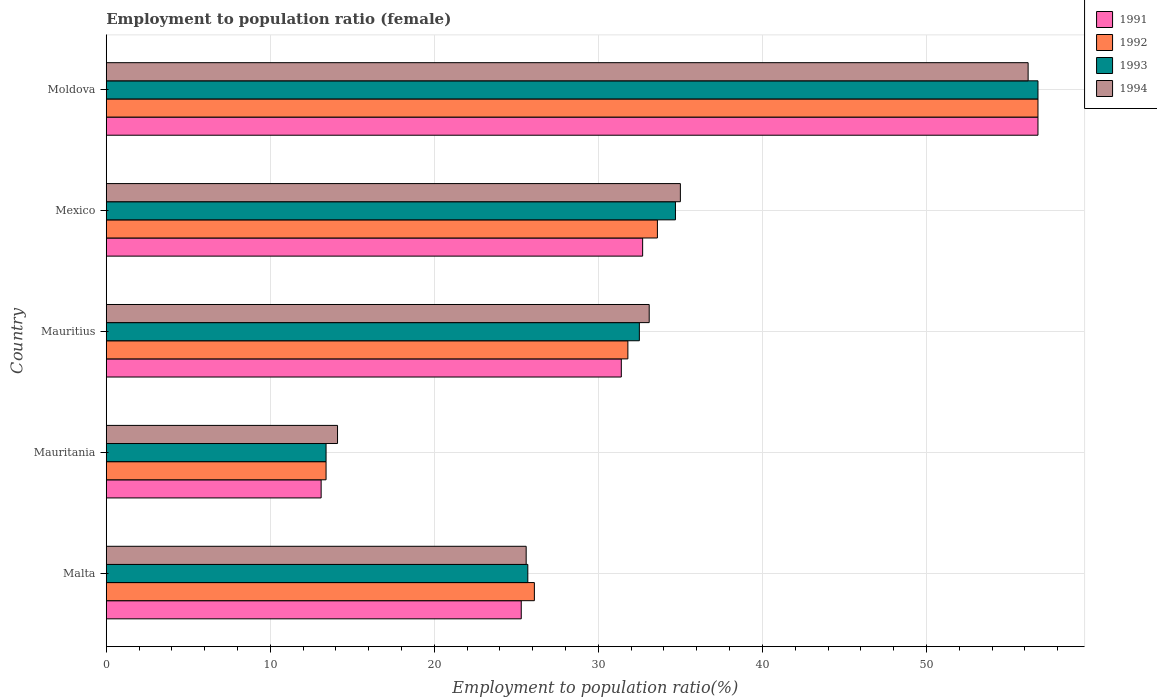How many groups of bars are there?
Provide a succinct answer. 5. Are the number of bars per tick equal to the number of legend labels?
Keep it short and to the point. Yes. How many bars are there on the 4th tick from the bottom?
Your answer should be very brief. 4. What is the label of the 5th group of bars from the top?
Give a very brief answer. Malta. What is the employment to population ratio in 1991 in Moldova?
Keep it short and to the point. 56.8. Across all countries, what is the maximum employment to population ratio in 1991?
Provide a succinct answer. 56.8. Across all countries, what is the minimum employment to population ratio in 1992?
Ensure brevity in your answer.  13.4. In which country was the employment to population ratio in 1994 maximum?
Offer a terse response. Moldova. In which country was the employment to population ratio in 1994 minimum?
Ensure brevity in your answer.  Mauritania. What is the total employment to population ratio in 1992 in the graph?
Keep it short and to the point. 161.7. What is the difference between the employment to population ratio in 1993 in Malta and that in Moldova?
Make the answer very short. -31.1. What is the difference between the employment to population ratio in 1994 in Mauritania and the employment to population ratio in 1992 in Mexico?
Provide a short and direct response. -19.5. What is the average employment to population ratio in 1992 per country?
Provide a succinct answer. 32.34. What is the difference between the employment to population ratio in 1993 and employment to population ratio in 1994 in Mauritius?
Your answer should be very brief. -0.6. In how many countries, is the employment to population ratio in 1992 greater than 4 %?
Your answer should be very brief. 5. What is the ratio of the employment to population ratio in 1993 in Mauritania to that in Mexico?
Keep it short and to the point. 0.39. Is the employment to population ratio in 1994 in Mauritius less than that in Mexico?
Your answer should be very brief. Yes. Is the difference between the employment to population ratio in 1993 in Malta and Mexico greater than the difference between the employment to population ratio in 1994 in Malta and Mexico?
Your answer should be compact. Yes. What is the difference between the highest and the second highest employment to population ratio in 1993?
Offer a terse response. 22.1. What is the difference between the highest and the lowest employment to population ratio in 1994?
Your answer should be compact. 42.1. In how many countries, is the employment to population ratio in 1992 greater than the average employment to population ratio in 1992 taken over all countries?
Make the answer very short. 2. What does the 1st bar from the bottom in Mexico represents?
Keep it short and to the point. 1991. Is it the case that in every country, the sum of the employment to population ratio in 1993 and employment to population ratio in 1992 is greater than the employment to population ratio in 1991?
Ensure brevity in your answer.  Yes. How many bars are there?
Give a very brief answer. 20. How many countries are there in the graph?
Your response must be concise. 5. Are the values on the major ticks of X-axis written in scientific E-notation?
Your response must be concise. No. How many legend labels are there?
Give a very brief answer. 4. How are the legend labels stacked?
Offer a very short reply. Vertical. What is the title of the graph?
Ensure brevity in your answer.  Employment to population ratio (female). What is the Employment to population ratio(%) in 1991 in Malta?
Keep it short and to the point. 25.3. What is the Employment to population ratio(%) of 1992 in Malta?
Offer a terse response. 26.1. What is the Employment to population ratio(%) in 1993 in Malta?
Give a very brief answer. 25.7. What is the Employment to population ratio(%) of 1994 in Malta?
Your response must be concise. 25.6. What is the Employment to population ratio(%) of 1991 in Mauritania?
Provide a succinct answer. 13.1. What is the Employment to population ratio(%) of 1992 in Mauritania?
Your answer should be compact. 13.4. What is the Employment to population ratio(%) in 1993 in Mauritania?
Offer a very short reply. 13.4. What is the Employment to population ratio(%) of 1994 in Mauritania?
Offer a very short reply. 14.1. What is the Employment to population ratio(%) of 1991 in Mauritius?
Provide a succinct answer. 31.4. What is the Employment to population ratio(%) of 1992 in Mauritius?
Ensure brevity in your answer.  31.8. What is the Employment to population ratio(%) in 1993 in Mauritius?
Keep it short and to the point. 32.5. What is the Employment to population ratio(%) in 1994 in Mauritius?
Make the answer very short. 33.1. What is the Employment to population ratio(%) of 1991 in Mexico?
Offer a terse response. 32.7. What is the Employment to population ratio(%) of 1992 in Mexico?
Offer a very short reply. 33.6. What is the Employment to population ratio(%) of 1993 in Mexico?
Offer a very short reply. 34.7. What is the Employment to population ratio(%) of 1991 in Moldova?
Provide a short and direct response. 56.8. What is the Employment to population ratio(%) of 1992 in Moldova?
Provide a short and direct response. 56.8. What is the Employment to population ratio(%) of 1993 in Moldova?
Provide a succinct answer. 56.8. What is the Employment to population ratio(%) in 1994 in Moldova?
Provide a short and direct response. 56.2. Across all countries, what is the maximum Employment to population ratio(%) in 1991?
Give a very brief answer. 56.8. Across all countries, what is the maximum Employment to population ratio(%) of 1992?
Give a very brief answer. 56.8. Across all countries, what is the maximum Employment to population ratio(%) of 1993?
Provide a succinct answer. 56.8. Across all countries, what is the maximum Employment to population ratio(%) of 1994?
Ensure brevity in your answer.  56.2. Across all countries, what is the minimum Employment to population ratio(%) in 1991?
Provide a short and direct response. 13.1. Across all countries, what is the minimum Employment to population ratio(%) in 1992?
Give a very brief answer. 13.4. Across all countries, what is the minimum Employment to population ratio(%) of 1993?
Make the answer very short. 13.4. Across all countries, what is the minimum Employment to population ratio(%) in 1994?
Your response must be concise. 14.1. What is the total Employment to population ratio(%) of 1991 in the graph?
Your answer should be very brief. 159.3. What is the total Employment to population ratio(%) in 1992 in the graph?
Provide a short and direct response. 161.7. What is the total Employment to population ratio(%) of 1993 in the graph?
Provide a short and direct response. 163.1. What is the total Employment to population ratio(%) in 1994 in the graph?
Provide a short and direct response. 164. What is the difference between the Employment to population ratio(%) in 1992 in Malta and that in Mauritania?
Give a very brief answer. 12.7. What is the difference between the Employment to population ratio(%) in 1994 in Malta and that in Mauritania?
Your response must be concise. 11.5. What is the difference between the Employment to population ratio(%) in 1993 in Malta and that in Mauritius?
Give a very brief answer. -6.8. What is the difference between the Employment to population ratio(%) in 1994 in Malta and that in Mauritius?
Provide a succinct answer. -7.5. What is the difference between the Employment to population ratio(%) in 1992 in Malta and that in Mexico?
Your answer should be compact. -7.5. What is the difference between the Employment to population ratio(%) of 1991 in Malta and that in Moldova?
Your answer should be compact. -31.5. What is the difference between the Employment to population ratio(%) in 1992 in Malta and that in Moldova?
Make the answer very short. -30.7. What is the difference between the Employment to population ratio(%) in 1993 in Malta and that in Moldova?
Your response must be concise. -31.1. What is the difference between the Employment to population ratio(%) of 1994 in Malta and that in Moldova?
Provide a short and direct response. -30.6. What is the difference between the Employment to population ratio(%) in 1991 in Mauritania and that in Mauritius?
Make the answer very short. -18.3. What is the difference between the Employment to population ratio(%) in 1992 in Mauritania and that in Mauritius?
Your answer should be very brief. -18.4. What is the difference between the Employment to population ratio(%) of 1993 in Mauritania and that in Mauritius?
Your response must be concise. -19.1. What is the difference between the Employment to population ratio(%) in 1994 in Mauritania and that in Mauritius?
Your answer should be compact. -19. What is the difference between the Employment to population ratio(%) in 1991 in Mauritania and that in Mexico?
Keep it short and to the point. -19.6. What is the difference between the Employment to population ratio(%) of 1992 in Mauritania and that in Mexico?
Your response must be concise. -20.2. What is the difference between the Employment to population ratio(%) of 1993 in Mauritania and that in Mexico?
Provide a succinct answer. -21.3. What is the difference between the Employment to population ratio(%) of 1994 in Mauritania and that in Mexico?
Provide a short and direct response. -20.9. What is the difference between the Employment to population ratio(%) of 1991 in Mauritania and that in Moldova?
Ensure brevity in your answer.  -43.7. What is the difference between the Employment to population ratio(%) in 1992 in Mauritania and that in Moldova?
Offer a terse response. -43.4. What is the difference between the Employment to population ratio(%) in 1993 in Mauritania and that in Moldova?
Ensure brevity in your answer.  -43.4. What is the difference between the Employment to population ratio(%) in 1994 in Mauritania and that in Moldova?
Ensure brevity in your answer.  -42.1. What is the difference between the Employment to population ratio(%) in 1991 in Mauritius and that in Mexico?
Ensure brevity in your answer.  -1.3. What is the difference between the Employment to population ratio(%) of 1994 in Mauritius and that in Mexico?
Keep it short and to the point. -1.9. What is the difference between the Employment to population ratio(%) in 1991 in Mauritius and that in Moldova?
Give a very brief answer. -25.4. What is the difference between the Employment to population ratio(%) of 1993 in Mauritius and that in Moldova?
Ensure brevity in your answer.  -24.3. What is the difference between the Employment to population ratio(%) in 1994 in Mauritius and that in Moldova?
Ensure brevity in your answer.  -23.1. What is the difference between the Employment to population ratio(%) of 1991 in Mexico and that in Moldova?
Give a very brief answer. -24.1. What is the difference between the Employment to population ratio(%) of 1992 in Mexico and that in Moldova?
Make the answer very short. -23.2. What is the difference between the Employment to population ratio(%) of 1993 in Mexico and that in Moldova?
Ensure brevity in your answer.  -22.1. What is the difference between the Employment to population ratio(%) of 1994 in Mexico and that in Moldova?
Your answer should be compact. -21.2. What is the difference between the Employment to population ratio(%) of 1991 in Malta and the Employment to population ratio(%) of 1994 in Mauritania?
Offer a terse response. 11.2. What is the difference between the Employment to population ratio(%) in 1992 in Malta and the Employment to population ratio(%) in 1994 in Mauritania?
Give a very brief answer. 12. What is the difference between the Employment to population ratio(%) in 1991 in Malta and the Employment to population ratio(%) in 1992 in Mauritius?
Your answer should be compact. -6.5. What is the difference between the Employment to population ratio(%) of 1991 in Malta and the Employment to population ratio(%) of 1993 in Mauritius?
Ensure brevity in your answer.  -7.2. What is the difference between the Employment to population ratio(%) in 1993 in Malta and the Employment to population ratio(%) in 1994 in Mauritius?
Your answer should be very brief. -7.4. What is the difference between the Employment to population ratio(%) in 1991 in Malta and the Employment to population ratio(%) in 1992 in Mexico?
Provide a short and direct response. -8.3. What is the difference between the Employment to population ratio(%) in 1991 in Malta and the Employment to population ratio(%) in 1993 in Mexico?
Ensure brevity in your answer.  -9.4. What is the difference between the Employment to population ratio(%) in 1991 in Malta and the Employment to population ratio(%) in 1994 in Mexico?
Offer a terse response. -9.7. What is the difference between the Employment to population ratio(%) of 1993 in Malta and the Employment to population ratio(%) of 1994 in Mexico?
Ensure brevity in your answer.  -9.3. What is the difference between the Employment to population ratio(%) of 1991 in Malta and the Employment to population ratio(%) of 1992 in Moldova?
Make the answer very short. -31.5. What is the difference between the Employment to population ratio(%) in 1991 in Malta and the Employment to population ratio(%) in 1993 in Moldova?
Your answer should be very brief. -31.5. What is the difference between the Employment to population ratio(%) in 1991 in Malta and the Employment to population ratio(%) in 1994 in Moldova?
Provide a short and direct response. -30.9. What is the difference between the Employment to population ratio(%) of 1992 in Malta and the Employment to population ratio(%) of 1993 in Moldova?
Provide a succinct answer. -30.7. What is the difference between the Employment to population ratio(%) in 1992 in Malta and the Employment to population ratio(%) in 1994 in Moldova?
Offer a very short reply. -30.1. What is the difference between the Employment to population ratio(%) of 1993 in Malta and the Employment to population ratio(%) of 1994 in Moldova?
Your response must be concise. -30.5. What is the difference between the Employment to population ratio(%) of 1991 in Mauritania and the Employment to population ratio(%) of 1992 in Mauritius?
Make the answer very short. -18.7. What is the difference between the Employment to population ratio(%) of 1991 in Mauritania and the Employment to population ratio(%) of 1993 in Mauritius?
Your answer should be compact. -19.4. What is the difference between the Employment to population ratio(%) of 1991 in Mauritania and the Employment to population ratio(%) of 1994 in Mauritius?
Provide a short and direct response. -20. What is the difference between the Employment to population ratio(%) of 1992 in Mauritania and the Employment to population ratio(%) of 1993 in Mauritius?
Offer a very short reply. -19.1. What is the difference between the Employment to population ratio(%) in 1992 in Mauritania and the Employment to population ratio(%) in 1994 in Mauritius?
Your response must be concise. -19.7. What is the difference between the Employment to population ratio(%) of 1993 in Mauritania and the Employment to population ratio(%) of 1994 in Mauritius?
Your response must be concise. -19.7. What is the difference between the Employment to population ratio(%) of 1991 in Mauritania and the Employment to population ratio(%) of 1992 in Mexico?
Provide a succinct answer. -20.5. What is the difference between the Employment to population ratio(%) in 1991 in Mauritania and the Employment to population ratio(%) in 1993 in Mexico?
Keep it short and to the point. -21.6. What is the difference between the Employment to population ratio(%) of 1991 in Mauritania and the Employment to population ratio(%) of 1994 in Mexico?
Offer a terse response. -21.9. What is the difference between the Employment to population ratio(%) of 1992 in Mauritania and the Employment to population ratio(%) of 1993 in Mexico?
Provide a short and direct response. -21.3. What is the difference between the Employment to population ratio(%) in 1992 in Mauritania and the Employment to population ratio(%) in 1994 in Mexico?
Your answer should be compact. -21.6. What is the difference between the Employment to population ratio(%) in 1993 in Mauritania and the Employment to population ratio(%) in 1994 in Mexico?
Ensure brevity in your answer.  -21.6. What is the difference between the Employment to population ratio(%) in 1991 in Mauritania and the Employment to population ratio(%) in 1992 in Moldova?
Give a very brief answer. -43.7. What is the difference between the Employment to population ratio(%) in 1991 in Mauritania and the Employment to population ratio(%) in 1993 in Moldova?
Your answer should be compact. -43.7. What is the difference between the Employment to population ratio(%) in 1991 in Mauritania and the Employment to population ratio(%) in 1994 in Moldova?
Offer a terse response. -43.1. What is the difference between the Employment to population ratio(%) in 1992 in Mauritania and the Employment to population ratio(%) in 1993 in Moldova?
Offer a terse response. -43.4. What is the difference between the Employment to population ratio(%) in 1992 in Mauritania and the Employment to population ratio(%) in 1994 in Moldova?
Offer a very short reply. -42.8. What is the difference between the Employment to population ratio(%) of 1993 in Mauritania and the Employment to population ratio(%) of 1994 in Moldova?
Provide a short and direct response. -42.8. What is the difference between the Employment to population ratio(%) of 1992 in Mauritius and the Employment to population ratio(%) of 1993 in Mexico?
Offer a very short reply. -2.9. What is the difference between the Employment to population ratio(%) in 1991 in Mauritius and the Employment to population ratio(%) in 1992 in Moldova?
Your response must be concise. -25.4. What is the difference between the Employment to population ratio(%) of 1991 in Mauritius and the Employment to population ratio(%) of 1993 in Moldova?
Offer a very short reply. -25.4. What is the difference between the Employment to population ratio(%) of 1991 in Mauritius and the Employment to population ratio(%) of 1994 in Moldova?
Give a very brief answer. -24.8. What is the difference between the Employment to population ratio(%) of 1992 in Mauritius and the Employment to population ratio(%) of 1993 in Moldova?
Ensure brevity in your answer.  -25. What is the difference between the Employment to population ratio(%) of 1992 in Mauritius and the Employment to population ratio(%) of 1994 in Moldova?
Keep it short and to the point. -24.4. What is the difference between the Employment to population ratio(%) in 1993 in Mauritius and the Employment to population ratio(%) in 1994 in Moldova?
Offer a terse response. -23.7. What is the difference between the Employment to population ratio(%) in 1991 in Mexico and the Employment to population ratio(%) in 1992 in Moldova?
Offer a very short reply. -24.1. What is the difference between the Employment to population ratio(%) of 1991 in Mexico and the Employment to population ratio(%) of 1993 in Moldova?
Ensure brevity in your answer.  -24.1. What is the difference between the Employment to population ratio(%) in 1991 in Mexico and the Employment to population ratio(%) in 1994 in Moldova?
Keep it short and to the point. -23.5. What is the difference between the Employment to population ratio(%) in 1992 in Mexico and the Employment to population ratio(%) in 1993 in Moldova?
Offer a terse response. -23.2. What is the difference between the Employment to population ratio(%) of 1992 in Mexico and the Employment to population ratio(%) of 1994 in Moldova?
Provide a short and direct response. -22.6. What is the difference between the Employment to population ratio(%) of 1993 in Mexico and the Employment to population ratio(%) of 1994 in Moldova?
Give a very brief answer. -21.5. What is the average Employment to population ratio(%) of 1991 per country?
Make the answer very short. 31.86. What is the average Employment to population ratio(%) in 1992 per country?
Give a very brief answer. 32.34. What is the average Employment to population ratio(%) in 1993 per country?
Make the answer very short. 32.62. What is the average Employment to population ratio(%) of 1994 per country?
Give a very brief answer. 32.8. What is the difference between the Employment to population ratio(%) of 1991 and Employment to population ratio(%) of 1992 in Malta?
Your response must be concise. -0.8. What is the difference between the Employment to population ratio(%) in 1991 and Employment to population ratio(%) in 1993 in Malta?
Give a very brief answer. -0.4. What is the difference between the Employment to population ratio(%) of 1992 and Employment to population ratio(%) of 1993 in Malta?
Your answer should be very brief. 0.4. What is the difference between the Employment to population ratio(%) of 1991 and Employment to population ratio(%) of 1993 in Mauritania?
Ensure brevity in your answer.  -0.3. What is the difference between the Employment to population ratio(%) in 1991 and Employment to population ratio(%) in 1994 in Mauritania?
Give a very brief answer. -1. What is the difference between the Employment to population ratio(%) in 1992 and Employment to population ratio(%) in 1993 in Mauritania?
Your answer should be compact. 0. What is the difference between the Employment to population ratio(%) in 1992 and Employment to population ratio(%) in 1994 in Mauritania?
Your answer should be very brief. -0.7. What is the difference between the Employment to population ratio(%) in 1991 and Employment to population ratio(%) in 1992 in Mauritius?
Keep it short and to the point. -0.4. What is the difference between the Employment to population ratio(%) of 1991 and Employment to population ratio(%) of 1993 in Mauritius?
Provide a succinct answer. -1.1. What is the difference between the Employment to population ratio(%) of 1992 and Employment to population ratio(%) of 1993 in Mauritius?
Provide a short and direct response. -0.7. What is the difference between the Employment to population ratio(%) of 1992 and Employment to population ratio(%) of 1994 in Mauritius?
Provide a succinct answer. -1.3. What is the difference between the Employment to population ratio(%) in 1991 and Employment to population ratio(%) in 1994 in Mexico?
Offer a terse response. -2.3. What is the difference between the Employment to population ratio(%) in 1992 and Employment to population ratio(%) in 1994 in Mexico?
Your answer should be compact. -1.4. What is the difference between the Employment to population ratio(%) in 1993 and Employment to population ratio(%) in 1994 in Mexico?
Provide a succinct answer. -0.3. What is the difference between the Employment to population ratio(%) of 1991 and Employment to population ratio(%) of 1992 in Moldova?
Provide a succinct answer. 0. What is the difference between the Employment to population ratio(%) of 1991 and Employment to population ratio(%) of 1993 in Moldova?
Give a very brief answer. 0. What is the difference between the Employment to population ratio(%) of 1991 and Employment to population ratio(%) of 1994 in Moldova?
Provide a succinct answer. 0.6. What is the ratio of the Employment to population ratio(%) in 1991 in Malta to that in Mauritania?
Keep it short and to the point. 1.93. What is the ratio of the Employment to population ratio(%) of 1992 in Malta to that in Mauritania?
Give a very brief answer. 1.95. What is the ratio of the Employment to population ratio(%) in 1993 in Malta to that in Mauritania?
Ensure brevity in your answer.  1.92. What is the ratio of the Employment to population ratio(%) of 1994 in Malta to that in Mauritania?
Your response must be concise. 1.82. What is the ratio of the Employment to population ratio(%) of 1991 in Malta to that in Mauritius?
Ensure brevity in your answer.  0.81. What is the ratio of the Employment to population ratio(%) in 1992 in Malta to that in Mauritius?
Provide a succinct answer. 0.82. What is the ratio of the Employment to population ratio(%) of 1993 in Malta to that in Mauritius?
Make the answer very short. 0.79. What is the ratio of the Employment to population ratio(%) in 1994 in Malta to that in Mauritius?
Offer a very short reply. 0.77. What is the ratio of the Employment to population ratio(%) in 1991 in Malta to that in Mexico?
Your answer should be compact. 0.77. What is the ratio of the Employment to population ratio(%) in 1992 in Malta to that in Mexico?
Keep it short and to the point. 0.78. What is the ratio of the Employment to population ratio(%) in 1993 in Malta to that in Mexico?
Your answer should be compact. 0.74. What is the ratio of the Employment to population ratio(%) in 1994 in Malta to that in Mexico?
Keep it short and to the point. 0.73. What is the ratio of the Employment to population ratio(%) in 1991 in Malta to that in Moldova?
Provide a succinct answer. 0.45. What is the ratio of the Employment to population ratio(%) of 1992 in Malta to that in Moldova?
Give a very brief answer. 0.46. What is the ratio of the Employment to population ratio(%) in 1993 in Malta to that in Moldova?
Ensure brevity in your answer.  0.45. What is the ratio of the Employment to population ratio(%) of 1994 in Malta to that in Moldova?
Provide a short and direct response. 0.46. What is the ratio of the Employment to population ratio(%) in 1991 in Mauritania to that in Mauritius?
Your answer should be compact. 0.42. What is the ratio of the Employment to population ratio(%) of 1992 in Mauritania to that in Mauritius?
Ensure brevity in your answer.  0.42. What is the ratio of the Employment to population ratio(%) of 1993 in Mauritania to that in Mauritius?
Offer a terse response. 0.41. What is the ratio of the Employment to population ratio(%) of 1994 in Mauritania to that in Mauritius?
Your response must be concise. 0.43. What is the ratio of the Employment to population ratio(%) of 1991 in Mauritania to that in Mexico?
Your response must be concise. 0.4. What is the ratio of the Employment to population ratio(%) in 1992 in Mauritania to that in Mexico?
Your answer should be compact. 0.4. What is the ratio of the Employment to population ratio(%) in 1993 in Mauritania to that in Mexico?
Offer a very short reply. 0.39. What is the ratio of the Employment to population ratio(%) of 1994 in Mauritania to that in Mexico?
Your answer should be compact. 0.4. What is the ratio of the Employment to population ratio(%) of 1991 in Mauritania to that in Moldova?
Your answer should be very brief. 0.23. What is the ratio of the Employment to population ratio(%) in 1992 in Mauritania to that in Moldova?
Keep it short and to the point. 0.24. What is the ratio of the Employment to population ratio(%) in 1993 in Mauritania to that in Moldova?
Your answer should be compact. 0.24. What is the ratio of the Employment to population ratio(%) of 1994 in Mauritania to that in Moldova?
Your answer should be compact. 0.25. What is the ratio of the Employment to population ratio(%) in 1991 in Mauritius to that in Mexico?
Give a very brief answer. 0.96. What is the ratio of the Employment to population ratio(%) in 1992 in Mauritius to that in Mexico?
Your answer should be very brief. 0.95. What is the ratio of the Employment to population ratio(%) in 1993 in Mauritius to that in Mexico?
Your response must be concise. 0.94. What is the ratio of the Employment to population ratio(%) of 1994 in Mauritius to that in Mexico?
Your answer should be very brief. 0.95. What is the ratio of the Employment to population ratio(%) of 1991 in Mauritius to that in Moldova?
Your answer should be very brief. 0.55. What is the ratio of the Employment to population ratio(%) of 1992 in Mauritius to that in Moldova?
Keep it short and to the point. 0.56. What is the ratio of the Employment to population ratio(%) of 1993 in Mauritius to that in Moldova?
Your answer should be very brief. 0.57. What is the ratio of the Employment to population ratio(%) in 1994 in Mauritius to that in Moldova?
Make the answer very short. 0.59. What is the ratio of the Employment to population ratio(%) in 1991 in Mexico to that in Moldova?
Your answer should be very brief. 0.58. What is the ratio of the Employment to population ratio(%) of 1992 in Mexico to that in Moldova?
Keep it short and to the point. 0.59. What is the ratio of the Employment to population ratio(%) in 1993 in Mexico to that in Moldova?
Make the answer very short. 0.61. What is the ratio of the Employment to population ratio(%) of 1994 in Mexico to that in Moldova?
Your answer should be compact. 0.62. What is the difference between the highest and the second highest Employment to population ratio(%) of 1991?
Keep it short and to the point. 24.1. What is the difference between the highest and the second highest Employment to population ratio(%) of 1992?
Offer a terse response. 23.2. What is the difference between the highest and the second highest Employment to population ratio(%) in 1993?
Keep it short and to the point. 22.1. What is the difference between the highest and the second highest Employment to population ratio(%) in 1994?
Your answer should be very brief. 21.2. What is the difference between the highest and the lowest Employment to population ratio(%) in 1991?
Keep it short and to the point. 43.7. What is the difference between the highest and the lowest Employment to population ratio(%) of 1992?
Give a very brief answer. 43.4. What is the difference between the highest and the lowest Employment to population ratio(%) in 1993?
Ensure brevity in your answer.  43.4. What is the difference between the highest and the lowest Employment to population ratio(%) of 1994?
Provide a succinct answer. 42.1. 